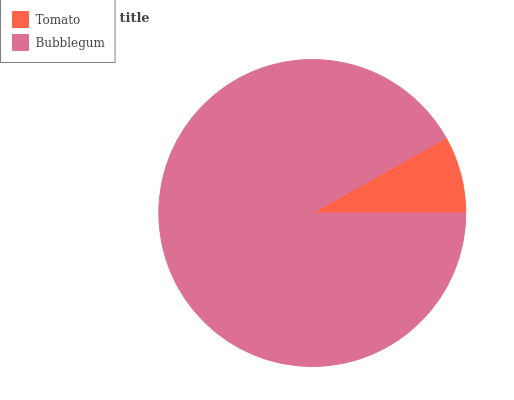Is Tomato the minimum?
Answer yes or no. Yes. Is Bubblegum the maximum?
Answer yes or no. Yes. Is Bubblegum the minimum?
Answer yes or no. No. Is Bubblegum greater than Tomato?
Answer yes or no. Yes. Is Tomato less than Bubblegum?
Answer yes or no. Yes. Is Tomato greater than Bubblegum?
Answer yes or no. No. Is Bubblegum less than Tomato?
Answer yes or no. No. Is Bubblegum the high median?
Answer yes or no. Yes. Is Tomato the low median?
Answer yes or no. Yes. Is Tomato the high median?
Answer yes or no. No. Is Bubblegum the low median?
Answer yes or no. No. 